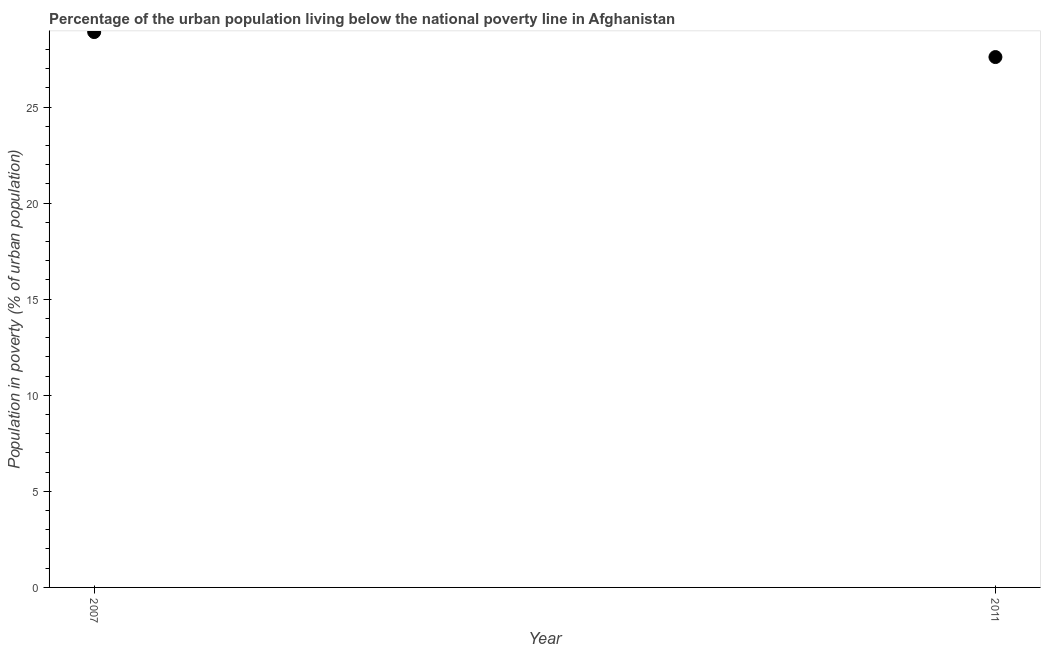What is the percentage of urban population living below poverty line in 2011?
Offer a terse response. 27.6. Across all years, what is the maximum percentage of urban population living below poverty line?
Your answer should be very brief. 28.9. Across all years, what is the minimum percentage of urban population living below poverty line?
Your answer should be very brief. 27.6. In which year was the percentage of urban population living below poverty line maximum?
Keep it short and to the point. 2007. What is the sum of the percentage of urban population living below poverty line?
Keep it short and to the point. 56.5. What is the difference between the percentage of urban population living below poverty line in 2007 and 2011?
Provide a succinct answer. 1.3. What is the average percentage of urban population living below poverty line per year?
Your answer should be compact. 28.25. What is the median percentage of urban population living below poverty line?
Give a very brief answer. 28.25. What is the ratio of the percentage of urban population living below poverty line in 2007 to that in 2011?
Provide a short and direct response. 1.05. Is the percentage of urban population living below poverty line in 2007 less than that in 2011?
Give a very brief answer. No. How many dotlines are there?
Ensure brevity in your answer.  1. Does the graph contain any zero values?
Give a very brief answer. No. What is the title of the graph?
Your answer should be compact. Percentage of the urban population living below the national poverty line in Afghanistan. What is the label or title of the Y-axis?
Provide a succinct answer. Population in poverty (% of urban population). What is the Population in poverty (% of urban population) in 2007?
Give a very brief answer. 28.9. What is the Population in poverty (% of urban population) in 2011?
Offer a terse response. 27.6. What is the ratio of the Population in poverty (% of urban population) in 2007 to that in 2011?
Your answer should be very brief. 1.05. 